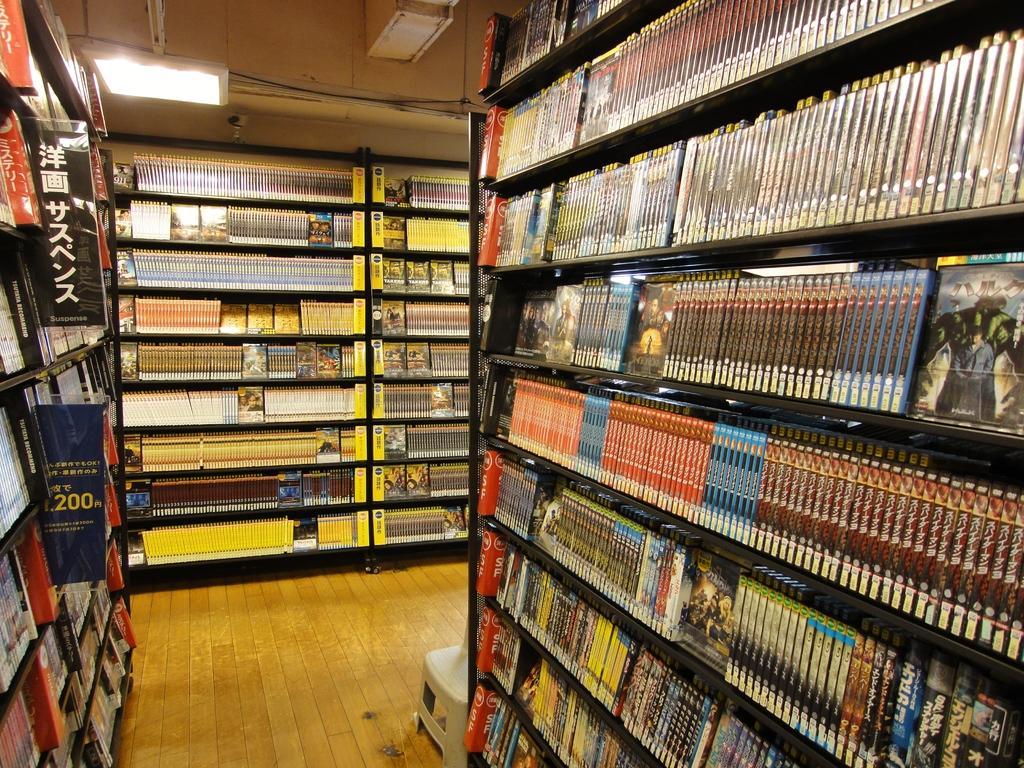Please provide a concise description of this image. In the image there are many rocks on either side with many books in it on the wooden floor and there are lights over the ceiling. 